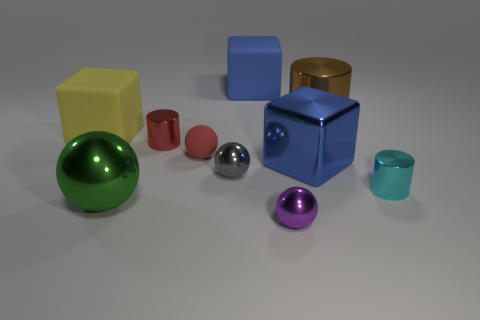The large shiny thing left of the large blue thing in front of the tiny ball that is behind the gray shiny thing is what color?
Your answer should be compact. Green. Are there any green objects that have the same shape as the tiny red rubber thing?
Ensure brevity in your answer.  Yes. Is the number of tiny purple shiny things that are in front of the purple ball greater than the number of red rubber spheres?
Give a very brief answer. No. How many metallic things are red cylinders or tiny cyan objects?
Your answer should be compact. 2. There is a sphere that is both in front of the metallic block and behind the green sphere; what is its size?
Provide a succinct answer. Small. There is a large block on the left side of the large metal ball; is there a tiny metal object behind it?
Offer a very short reply. No. There is a big blue metal block; how many gray spheres are to the right of it?
Give a very brief answer. 0. What is the color of the tiny rubber thing that is the same shape as the gray shiny object?
Keep it short and to the point. Red. Are the cylinder that is to the left of the small gray metallic sphere and the big object in front of the tiny cyan cylinder made of the same material?
Keep it short and to the point. Yes. There is a large metal cylinder; is its color the same as the large object behind the brown metal object?
Provide a succinct answer. No. 